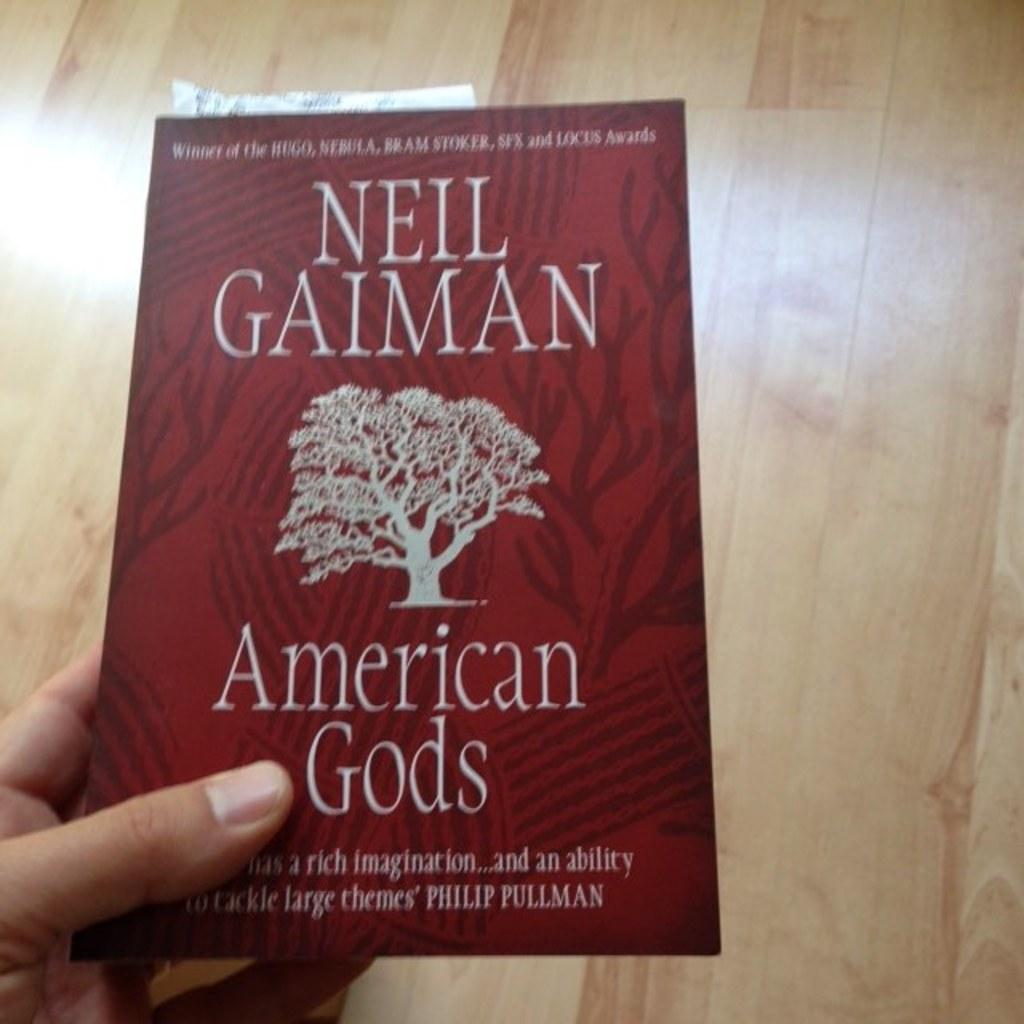What authors name is at the top of the book?
Keep it short and to the point. Neil gaiman. What is the title of this book?
Offer a terse response. American gods. 